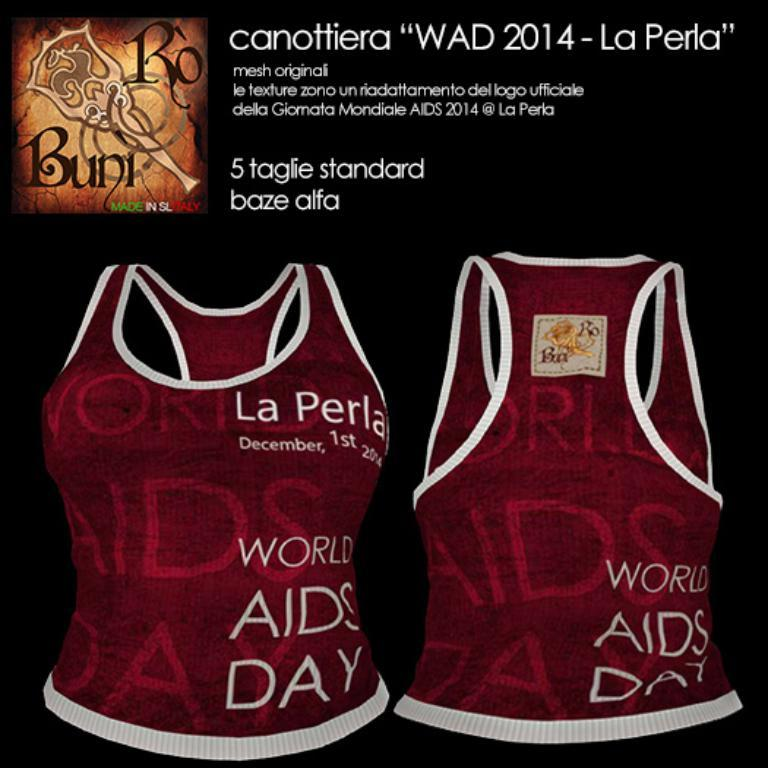<image>
Create a compact narrative representing the image presented. An advertisement with two shirts that say La Perla on them. 